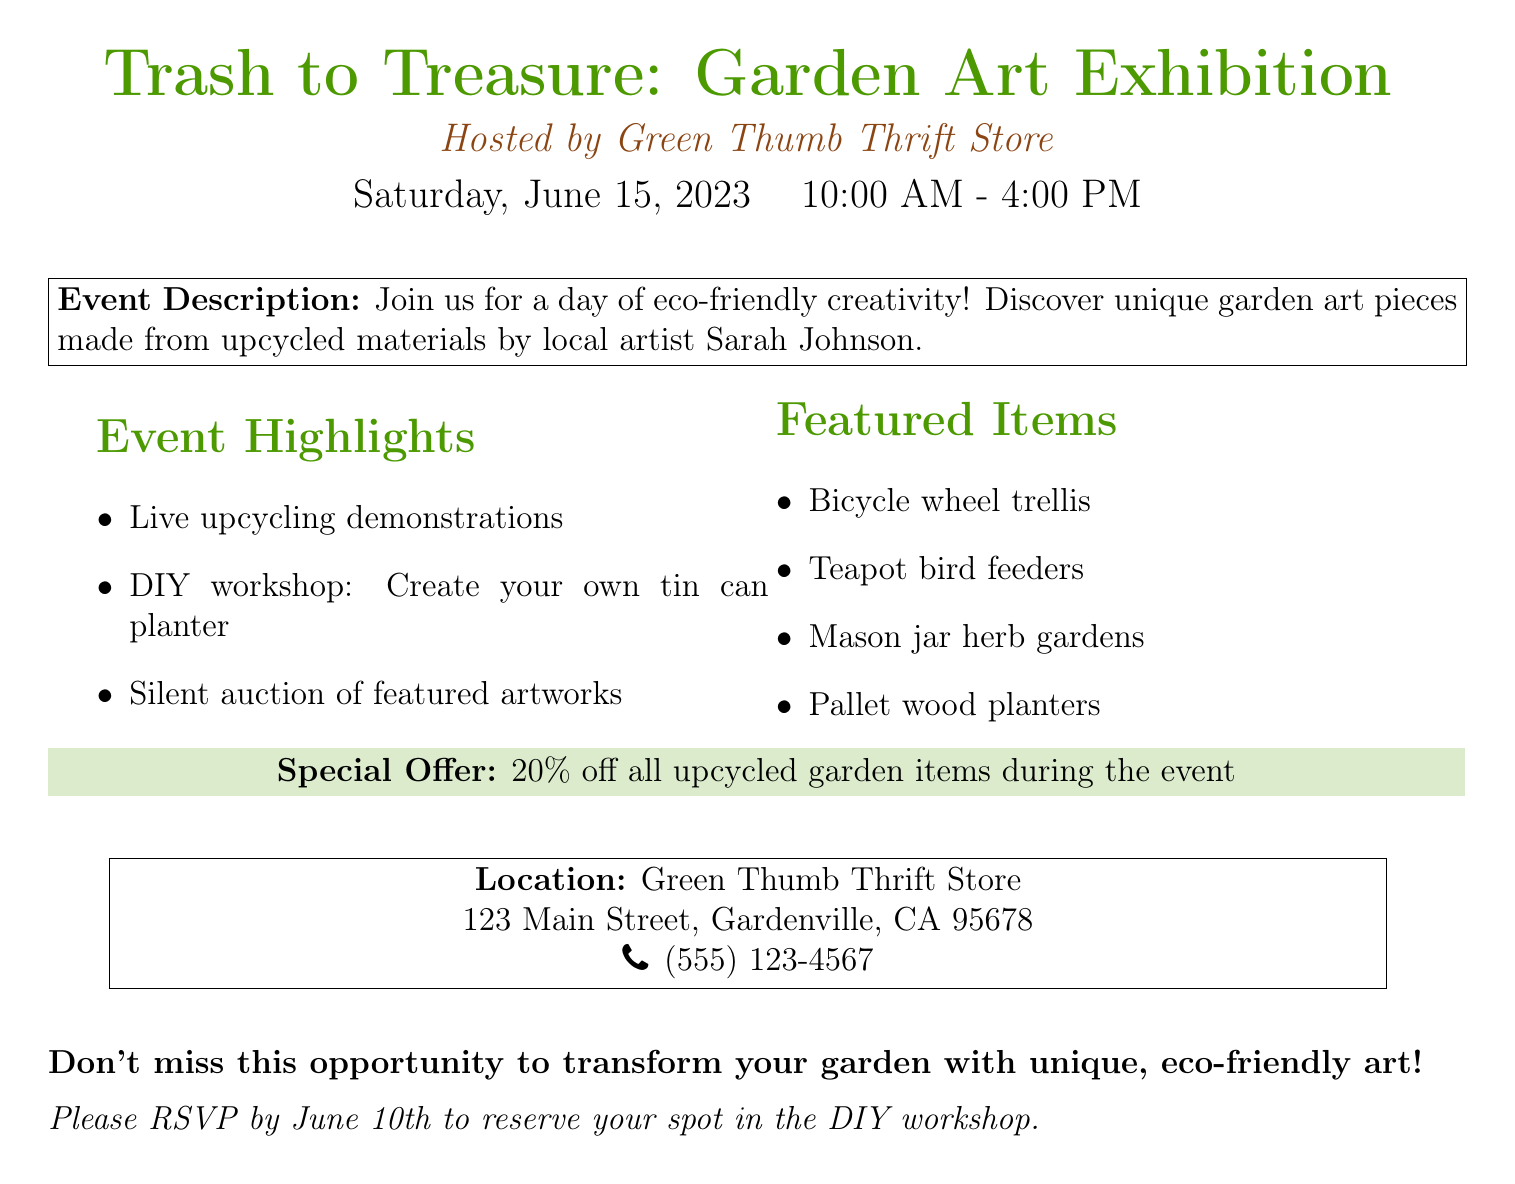What is the name of the exhibition? The exhibition is titled "Trash to Treasure: Garden Art Exhibition" as stated at the top of the document.
Answer: Trash to Treasure: Garden Art Exhibition Who is hosting the event? The document specifies that the event is hosted by Green Thumb Thrift Store.
Answer: Green Thumb Thrift Store What date is the exhibition being held? The date of the exhibition is mentioned as Saturday, June 15, 2023.
Answer: Saturday, June 15, 2023 What time does the event start? The document indicates that the event starts at 10:00 AM.
Answer: 10:00 AM How much of a discount is being offered on upcycled garden items? A special offer of 20% off all upcycled garden items during the event is mentioned in the document.
Answer: 20% Who is the featured artist? The document provides the name of the local artist as Sarah Johnson.
Answer: Sarah Johnson What is one of the featured items at the exhibition? The document lists several featured items, one of which is the bicycle wheel trellis.
Answer: Bicycle wheel trellis What type of workshop will be available at the event? The document states that there will be a DIY workshop to create your own tin can planter.
Answer: DIY workshop: Create your own tin can planter What is the RSVP deadline for the workshop? According to the document, RSVPs must be made by June 10th to reserve a spot.
Answer: June 10th 